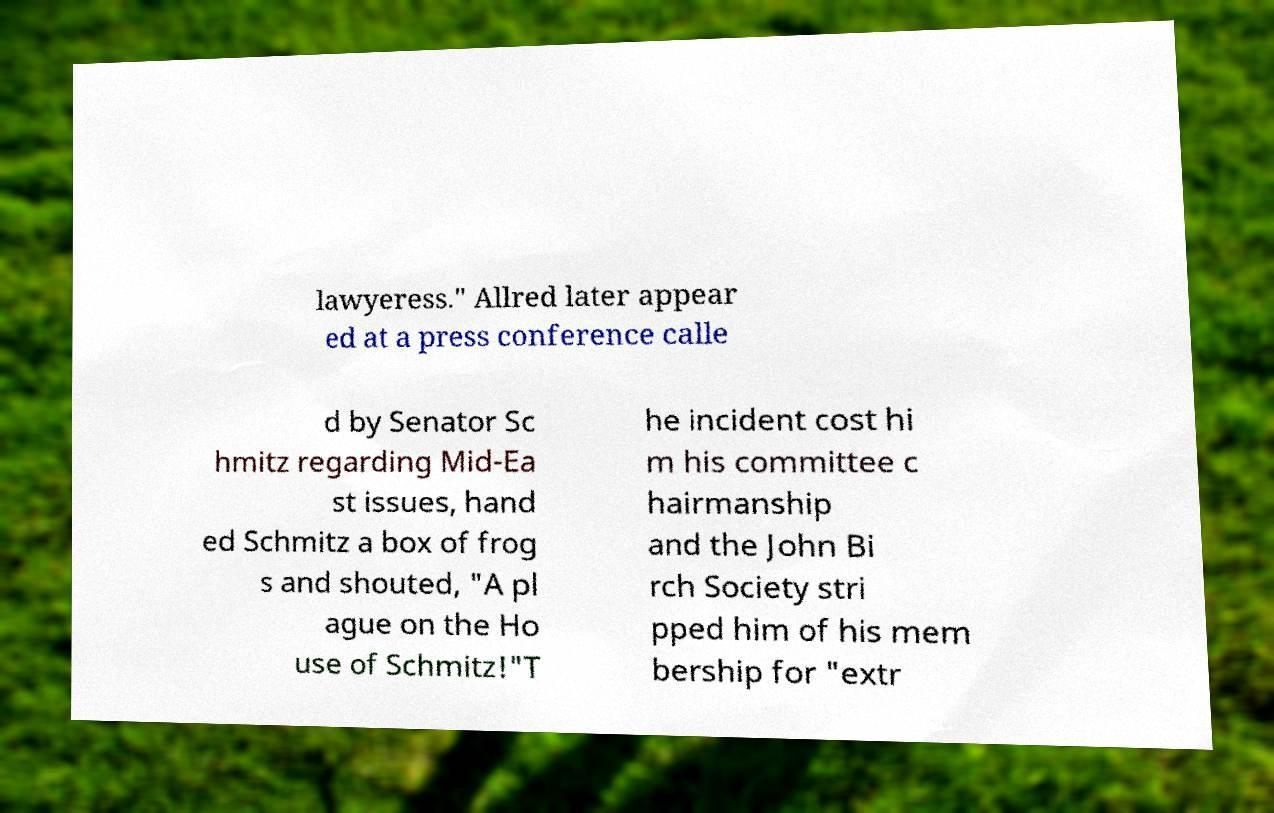There's text embedded in this image that I need extracted. Can you transcribe it verbatim? lawyeress." Allred later appear ed at a press conference calle d by Senator Sc hmitz regarding Mid-Ea st issues, hand ed Schmitz a box of frog s and shouted, "A pl ague on the Ho use of Schmitz!"T he incident cost hi m his committee c hairmanship and the John Bi rch Society stri pped him of his mem bership for "extr 